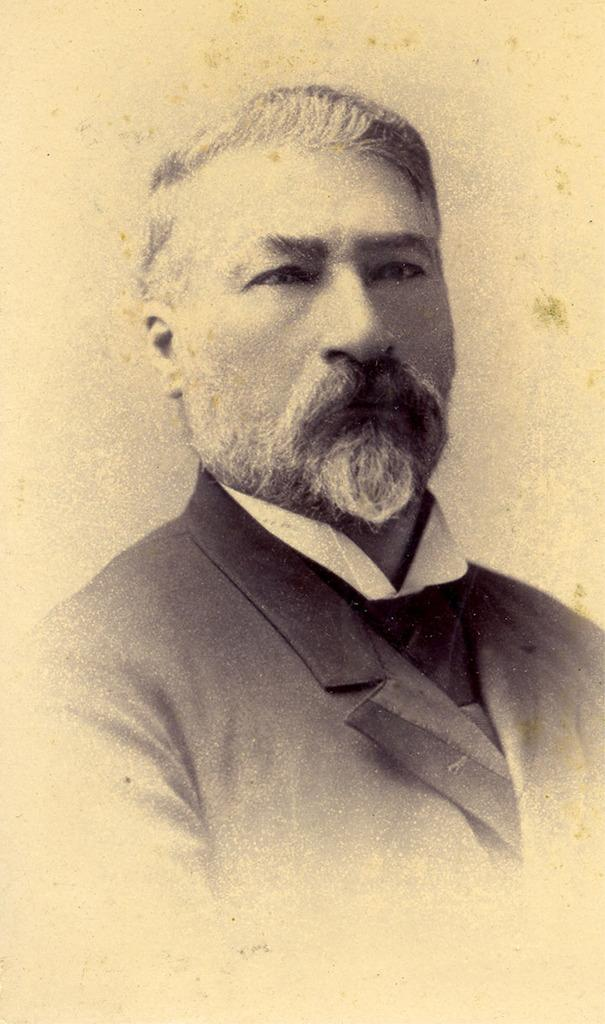Who is present in the image? There is a man in the image. What can be seen behind the man in the image? The background of the image is white. How much money is the man holding in the image? There is no indication of money in the image; the man is not holding any visible objects. 